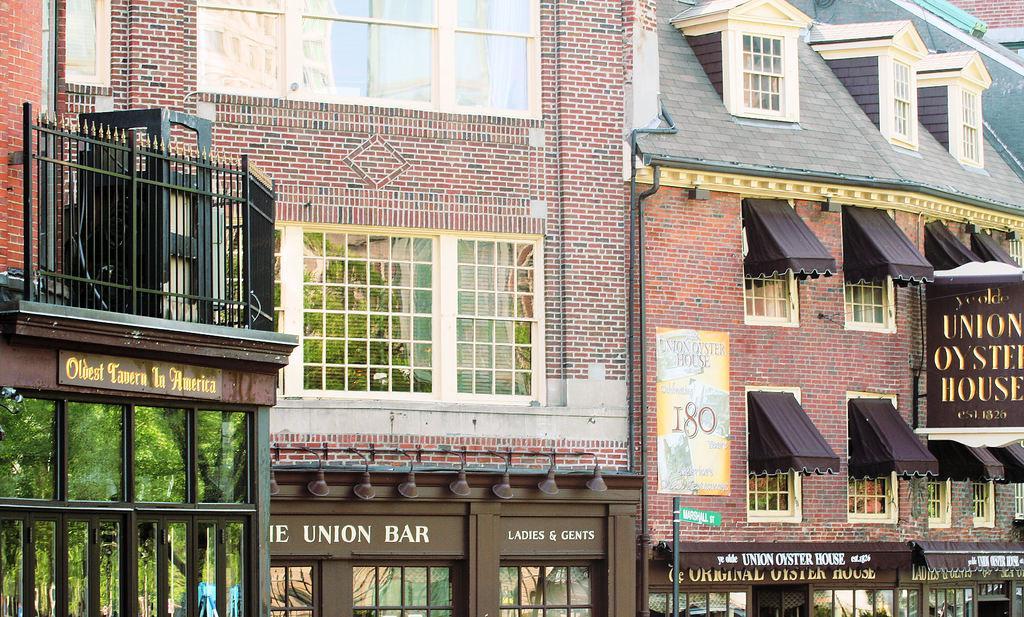Can you describe this image briefly? In this picture we can see a brown color house with white windows. On the bottom side there are some shops. On the left side we can see the black railing balcony. 